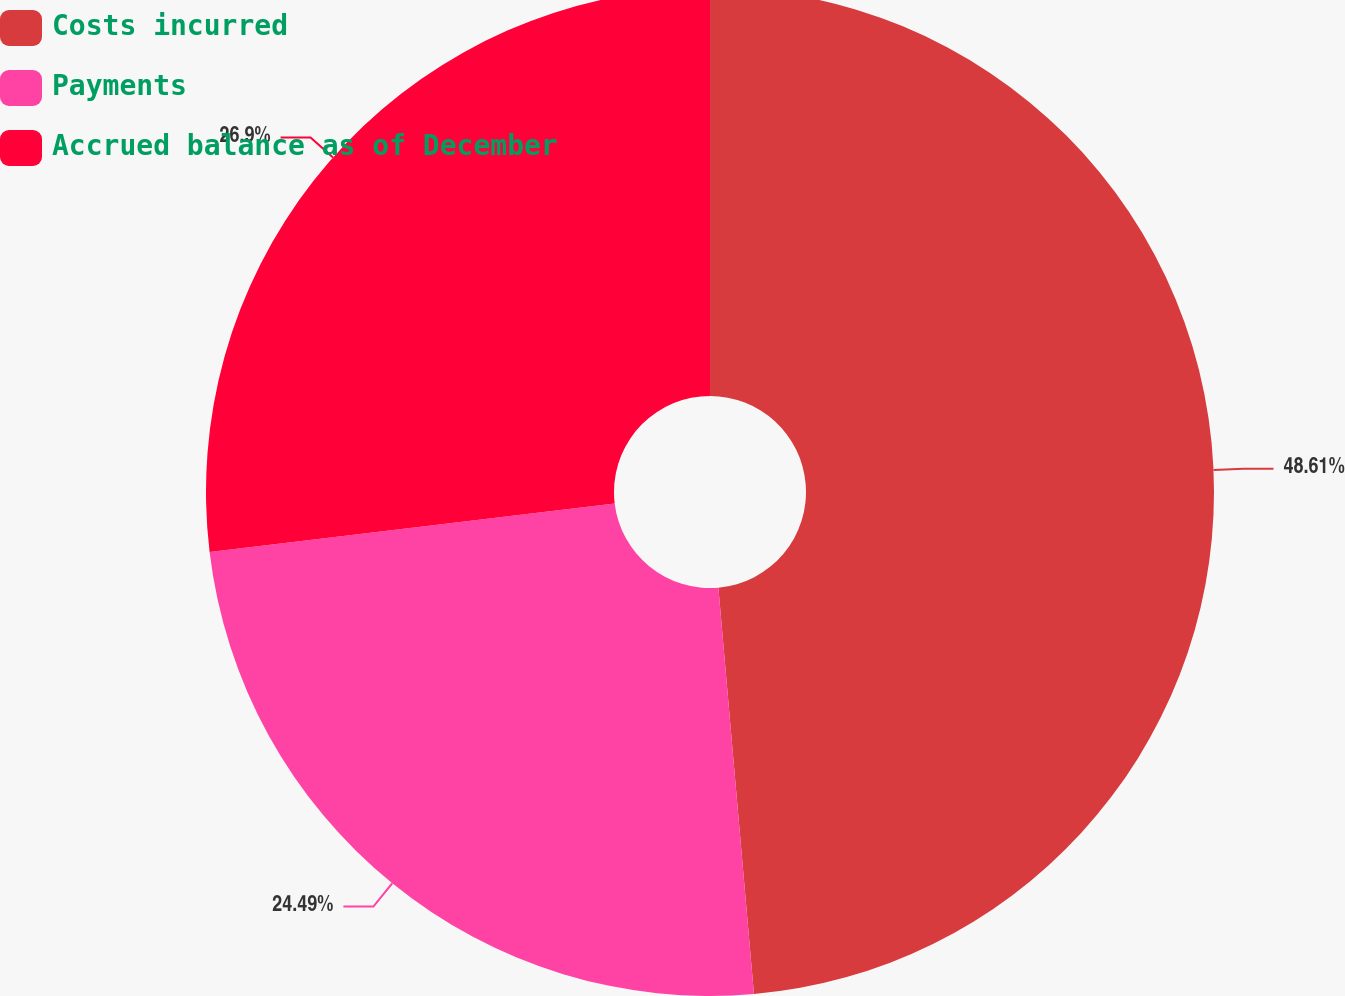Convert chart to OTSL. <chart><loc_0><loc_0><loc_500><loc_500><pie_chart><fcel>Costs incurred<fcel>Payments<fcel>Accrued balance as of December<nl><fcel>48.61%<fcel>24.49%<fcel>26.9%<nl></chart> 